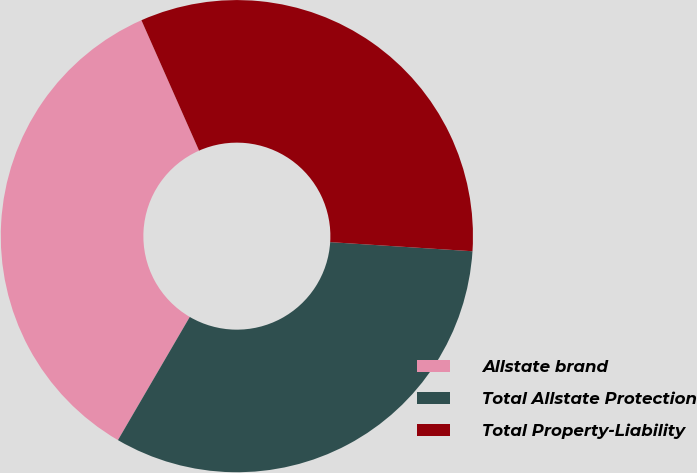Convert chart. <chart><loc_0><loc_0><loc_500><loc_500><pie_chart><fcel>Allstate brand<fcel>Total Allstate Protection<fcel>Total Property-Liability<nl><fcel>34.97%<fcel>32.38%<fcel>32.64%<nl></chart> 